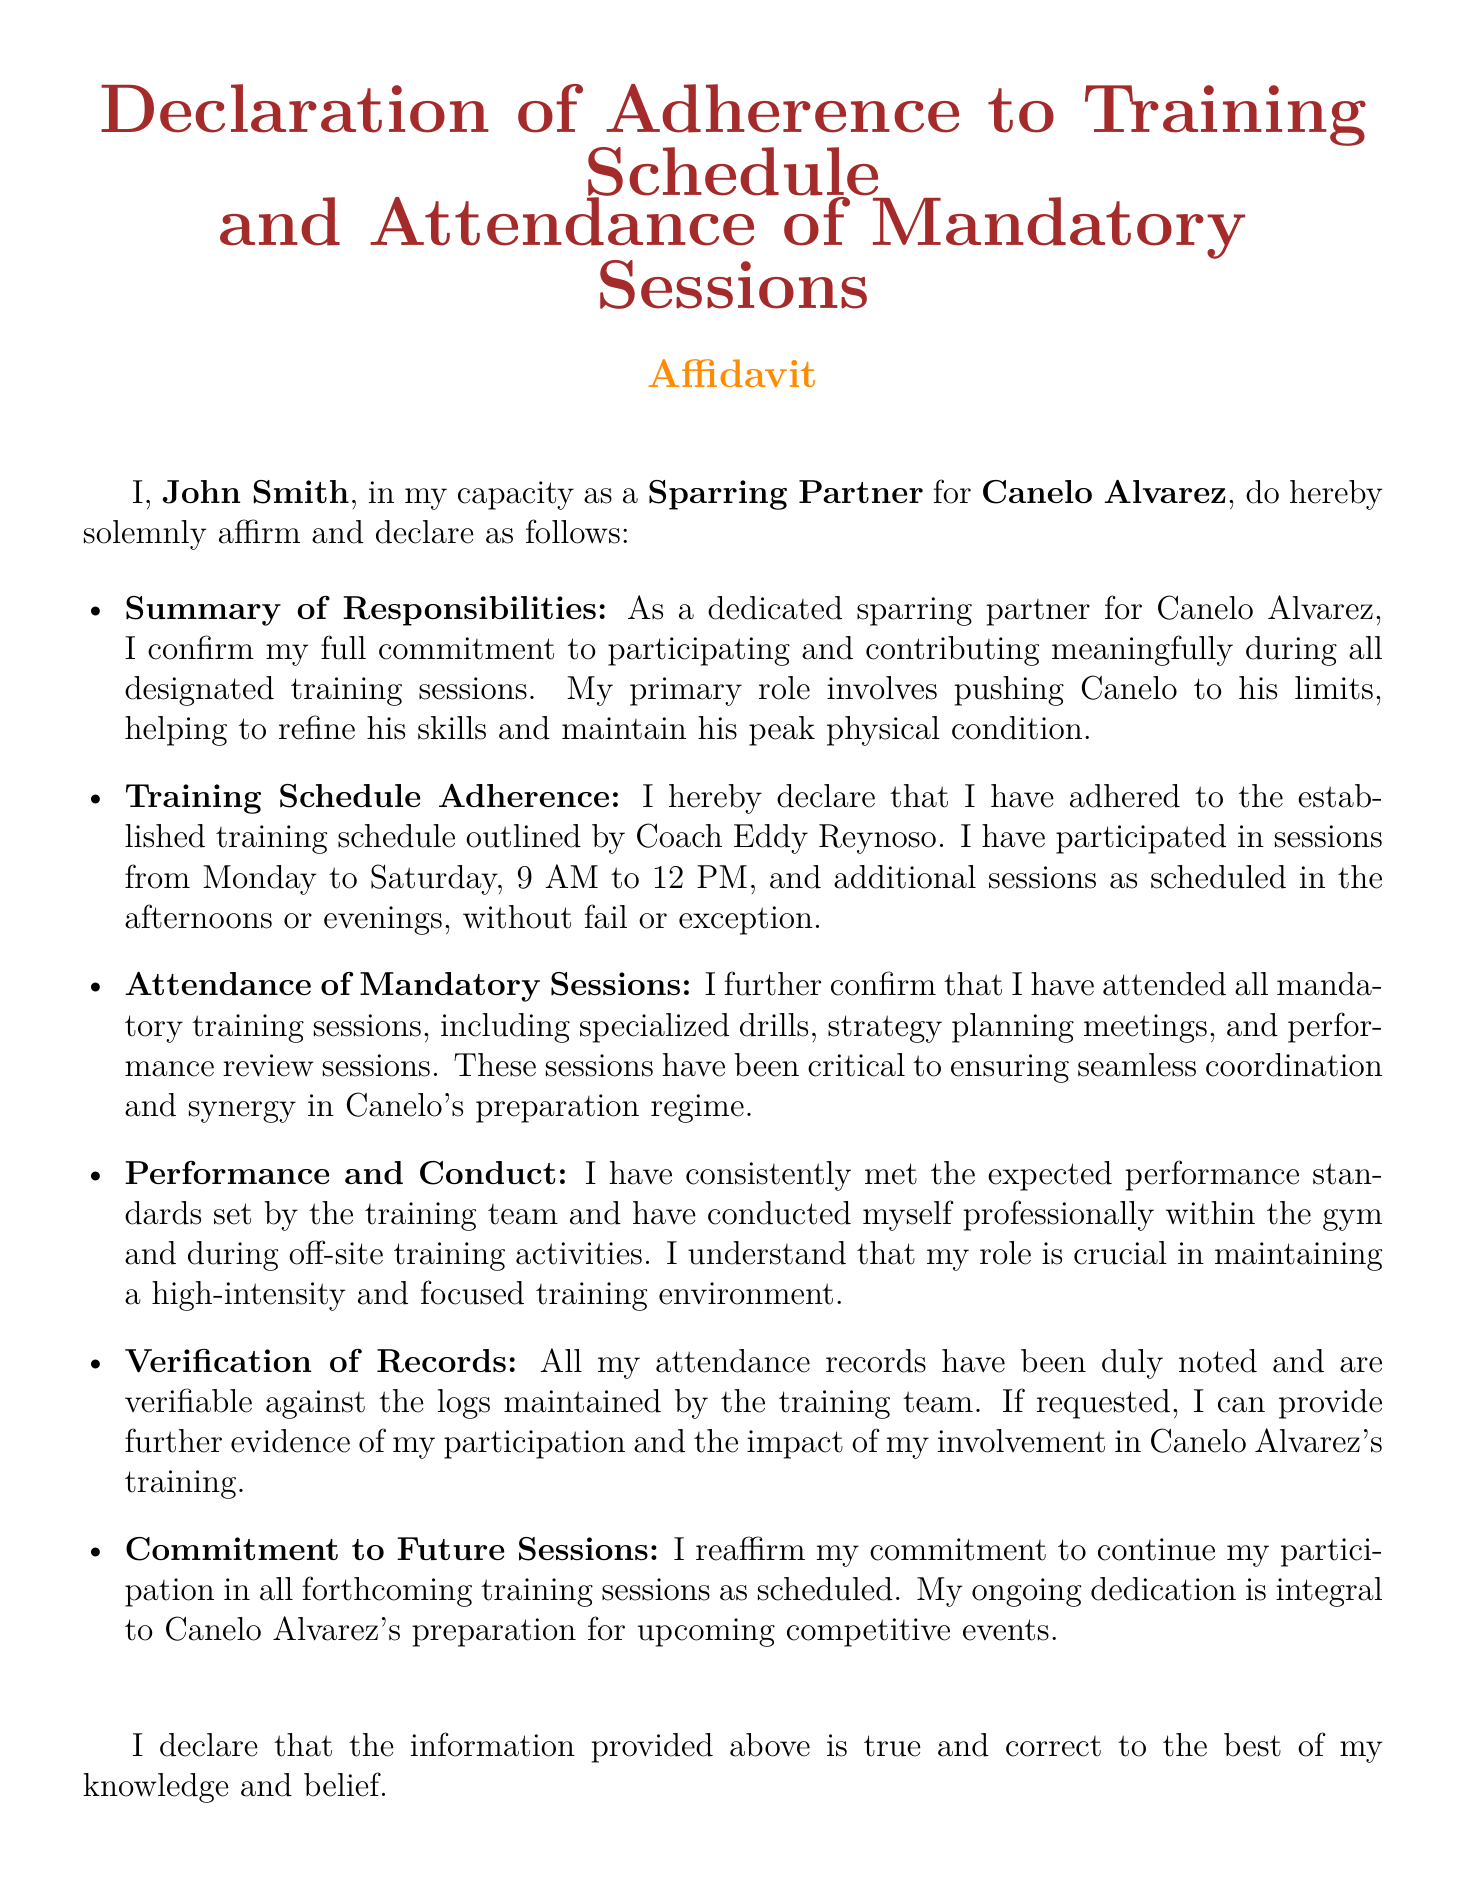What is the name of the sparring partner? The document states that the sparring partner's name is John Smith.
Answer: John Smith What is the position of the individual affirming the affidavit? The document mentions that John Smith is affirming as a Sparring Partner.
Answer: Sparring Partner What is the training schedule mentioned in the affidavit? The affidavit outlines that training sessions are held Monday to Saturday, from 9 AM to 12 PM.
Answer: Monday to Saturday, 9 AM to 12 PM What is the date of the affidavit? The document provides a specific date at the end, which is required for the legal declaration.
Answer: September 30, 2023 Who is the coach mentioned in the affidavit? The document specifies that the established training schedule is outlined by Coach Eddy Reynoso.
Answer: Coach Eddy Reynoso How many days per week does John Smith participate in training sessions? The document indicates that John Smith participates from Monday to Saturday, which accounts for 6 days.
Answer: 6 days What evidence can John Smith provide regarding his attendance? The affidavit states that his attendance records are verifiable against the logs maintained by the training team.
Answer: Attendance records What is John Smith's commitment towards future sessions? The document confirms that he reaffirms his commitment to participate in all forthcoming training sessions as scheduled.
Answer: Commitment to future sessions What types of sessions does John Smith mention attending? The affidavit mentions attendance of specialized drills, strategy planning meetings, and performance review sessions.
Answer: Specialized drills, strategy planning meetings, performance review sessions 